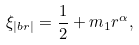<formula> <loc_0><loc_0><loc_500><loc_500>\xi _ { | b r | } = \frac { 1 } { 2 } + m _ { 1 } r ^ { \alpha } ,</formula> 